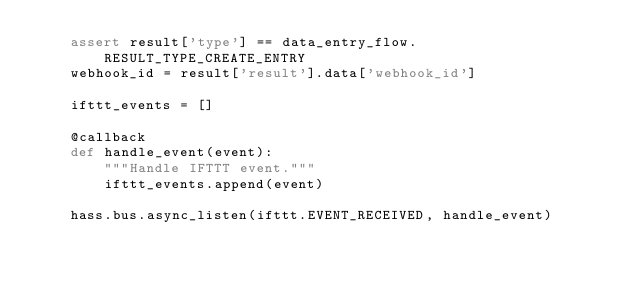<code> <loc_0><loc_0><loc_500><loc_500><_Python_>    assert result['type'] == data_entry_flow.RESULT_TYPE_CREATE_ENTRY
    webhook_id = result['result'].data['webhook_id']

    ifttt_events = []

    @callback
    def handle_event(event):
        """Handle IFTTT event."""
        ifttt_events.append(event)

    hass.bus.async_listen(ifttt.EVENT_RECEIVED, handle_event)
</code> 